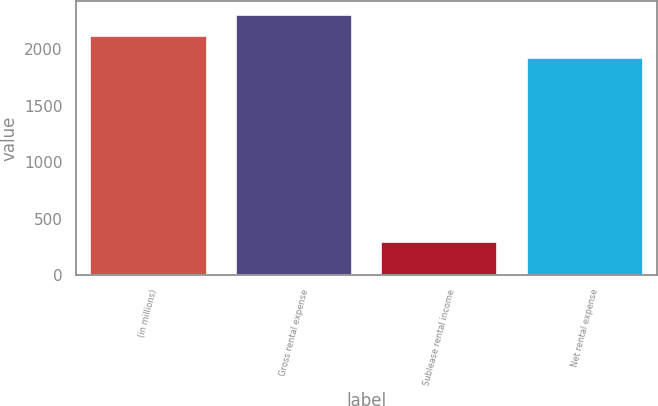<chart> <loc_0><loc_0><loc_500><loc_500><bar_chart><fcel>(in millions)<fcel>Gross rental expense<fcel>Sublease rental income<fcel>Net rental expense<nl><fcel>2116.4<fcel>2308.8<fcel>288<fcel>1924<nl></chart> 